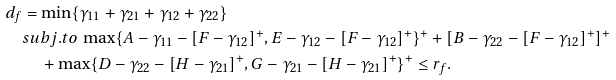Convert formula to latex. <formula><loc_0><loc_0><loc_500><loc_500>d _ { f } & = \min \{ \gamma _ { 1 1 } + \gamma _ { 2 1 } + \gamma _ { 1 2 } + \gamma _ { 2 2 } \} \\ & s u b j . t o \, \max \{ A - \gamma _ { 1 1 } - [ F - \gamma _ { 1 2 } ] ^ { + } , E - \gamma _ { 1 2 } - [ F - \gamma _ { 1 2 } ] ^ { + } \} ^ { + } + [ B - \gamma _ { 2 2 } - [ F - \gamma _ { 1 2 } ] ^ { + } ] ^ { + } \\ & \quad + \max \{ D - \gamma _ { 2 2 } - [ H - \gamma _ { 2 1 } ] ^ { + } , G - \gamma _ { 2 1 } - [ H - \gamma _ { 2 1 } ] ^ { + } \} ^ { + } \leq r _ { f } .</formula> 